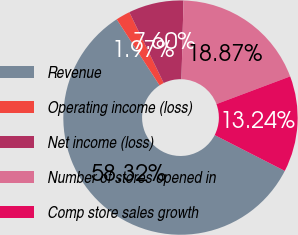<chart> <loc_0><loc_0><loc_500><loc_500><pie_chart><fcel>Revenue<fcel>Operating income (loss)<fcel>Net income (loss)<fcel>Number of stores opened in<fcel>Comp store sales growth<nl><fcel>58.32%<fcel>1.97%<fcel>7.6%<fcel>18.87%<fcel>13.24%<nl></chart> 